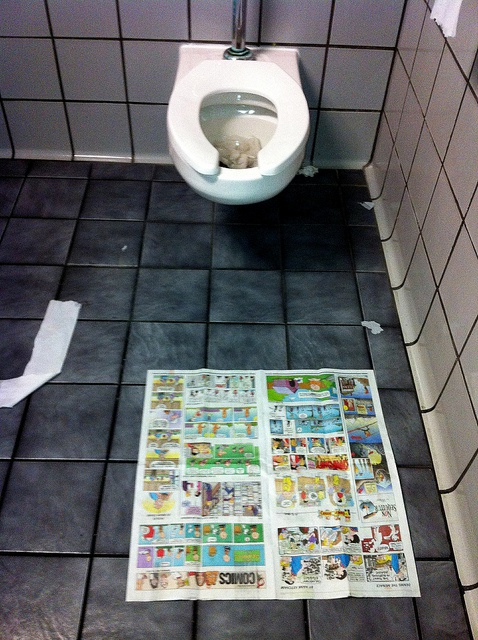Describe the objects in this image and their specific colors. I can see a toilet in gray, white, darkgray, and black tones in this image. 